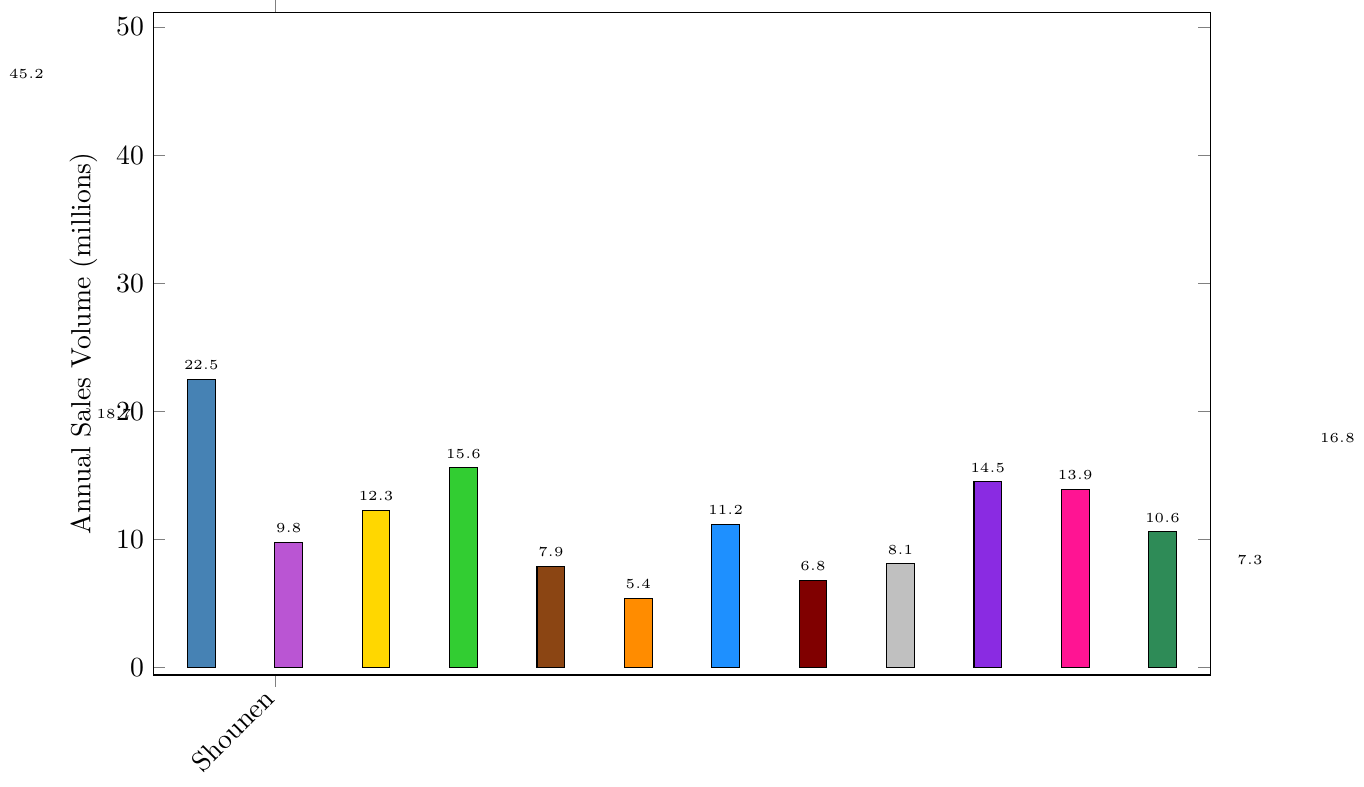Which demographic category has the highest annual sales volume? The highest annual sales volume can be identified by looking at the tallest bar in the figure. By comparing the height of all the bars, we can see that the Shounen category is the tallest.
Answer: Shounen What is the combined sales volume of the Seinen and Shoujo categories? To find the combined sales volume, we add the sales volumes of Seinen (22.5 million) and Shoujo (18.7 million). So, 22.5 + 18.7 = 41.2 million.
Answer: 41.2 million Which category has the lower sales volume: Josei or Mecha Manga? By comparing the heights of the bars for Josei and Mecha Manga, we can see that the Josei category (9.8 million) is lower than the Mecha Manga category (8.1 million).
Answer: Mecha Manga How much greater is the sales volume of Shounen compared to Fantasy Manga? To find the difference in sales volumes, subtract the sales volume of Fantasy Manga (16.8 million) from Shounen (45.2 million). So, 45.2 - 16.8 = 28.4 million.
Answer: 28.4 million Which category has a sales volume closest to 10 million? We need to find the category whose bar height represents a value close to 10 million. By checking the figure, we see Slice of Life Manga with 10.6 million fits this criterion.
Answer: Slice of Life Manga What is the average sales volume of the Kodomo, Young Adult, and Adult categories? To find the average sales volume, add up the sales volumes of Kodomo (12.3 million), Young Adult (15.6 million), and Adult (7.9 million) and divide by 3. So, (12.3 + 15.6 + 7.9) / 3 = 11.93 million.
Answer: 11.93 million Which categories have an annual sales volume less than 10 million? We need to identify the bars that have a height representing less than 10 million sales. These categories are Josei (9.8 million), Adult (7.9 million), Gag Manga (5.4 million), Horror Manga (6.8 million), Mecha Manga (8.1 million), and Historical Manga (7.3 million).
Answer: Josei, Adult, Gag Manga, Horror Manga, Mecha Manga, Historical Manga Rank the following categories from highest to lowest sales volume: Horror Manga, Sports Manga, and Romance Manga. By comparing the heights of the bars for Horror Manga (6.8 million), Sports Manga (11.2 million), and Romance Manga (13.9 million), we rank them as Romance Manga > Sports Manga > Horror Manga.
Answer: Romance Manga, Sports Manga, Horror Manga Is the sales volume of Slice of Life Manga greater than that of Isekai Manga and Romance Manga combined? To check this, compare the sales volume of Slice of Life Manga (10.6 million) to the sum of Isekai Manga (14.5 million) and Romance Manga (13.9 million). The combined volume is 14.5 + 13.9 = 28.4 million, which is greater than 10.6 million.
Answer: No What is the total sales volume of all categories combined? Add the sales volumes of all categories: 45.2 + 18.7 + 22.5 + 9.8 + 12.3 + 15.6 + 7.9 + 5.4 + 11.2 + 6.8 + 8.1 + 14.5 + 13.9 + 10.6 + 7.3 + 16.8 = 226.6 million.
Answer: 226.6 million 